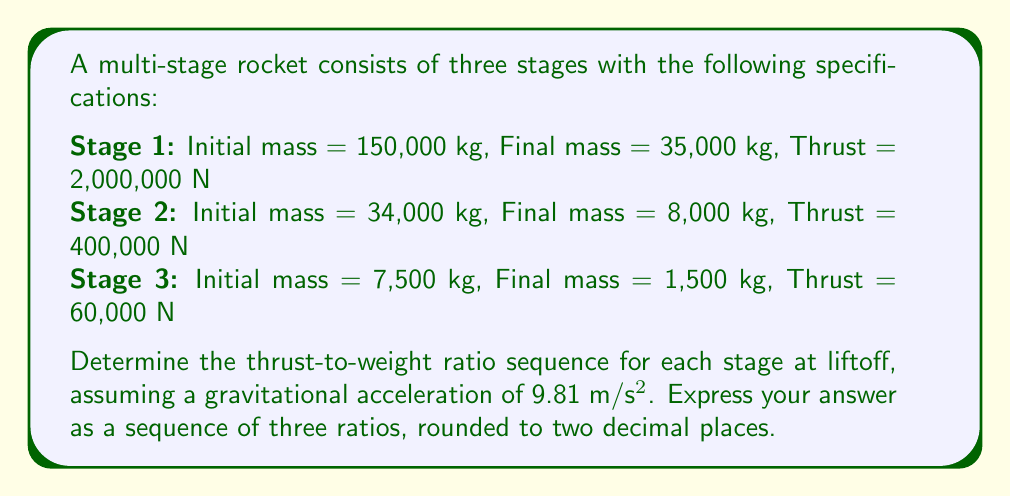Can you answer this question? To solve this problem, we need to calculate the thrust-to-weight ratio for each stage at liftoff. The thrust-to-weight ratio is given by the formula:

$$ \text{Thrust-to-Weight Ratio} = \frac{\text{Thrust}}{\text{Weight}} = \frac{\text{Thrust}}{\text{Mass} \times g} $$

Where $g$ is the gravitational acceleration (9.81 m/s²).

For each stage, we'll use the initial mass, as we're calculating the ratio at liftoff.

Stage 1:
$$ \text{Ratio}_1 = \frac{2,000,000 \text{ N}}{150,000 \text{ kg} \times 9.81 \text{ m/s²}} = \frac{2,000,000}{1,471,500} \approx 1.36 $$

Stage 2:
$$ \text{Ratio}_2 = \frac{400,000 \text{ N}}{34,000 \text{ kg} \times 9.81 \text{ m/s²}} = \frac{400,000}{333,540} \approx 1.20 $$

Stage 3:
$$ \text{Ratio}_3 = \frac{60,000 \text{ N}}{7,500 \text{ kg} \times 9.81 \text{ m/s²}} = \frac{60,000}{73,575} \approx 0.82 $$

The sequence of thrust-to-weight ratios for the three stages at liftoff is therefore (1.36, 1.20, 0.82).
Answer: (1.36, 1.20, 0.82) 